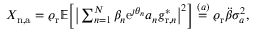Convert formula to latex. <formula><loc_0><loc_0><loc_500><loc_500>\begin{array} { r } { X _ { n , a } = \varrho _ { r } \mathbb { E } \left [ \left | \sum _ { n = 1 } ^ { N } \beta _ { n } e ^ { \jmath \theta _ { n } } a _ { n } g _ { r , n } ^ { * } \right | ^ { 2 } \right ] \overset { ( a ) } { = } \varrho _ { r } \ddot { \beta } \sigma _ { a } ^ { 2 } , } \end{array}</formula> 